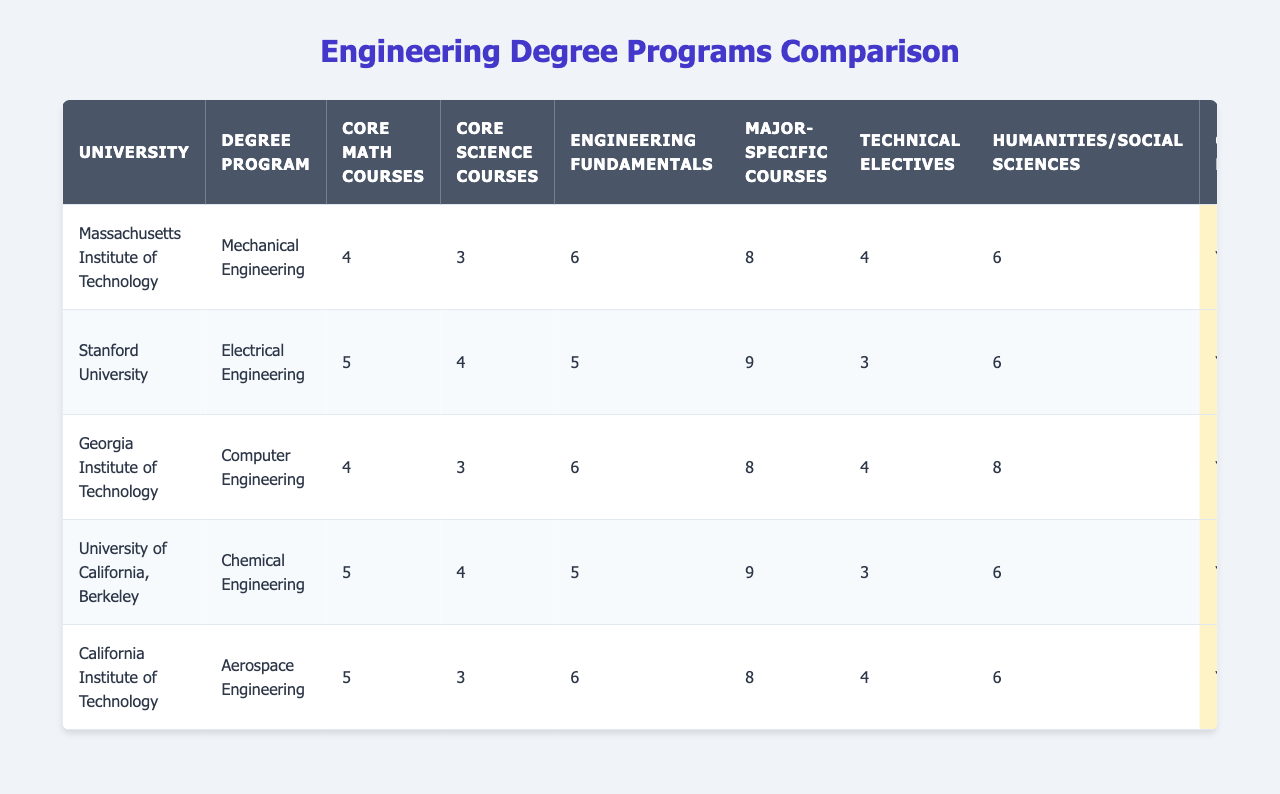What is the university with the most core math courses required for engineering? Referring to the table, Stanford University requires 5 core math courses, which is the highest among all the universities listed.
Answer: Stanford University Which degree program has the highest average class size? By examining the table, the average class size for the Chemical Engineering program at the University of California, Berkeley, is 40, which is the highest.
Answer: Chemical Engineering (University of California, Berkeley) Is the internship requirement mandatory for mechanical engineering programs? The internship requirement for the Mechanical Engineering program at MIT is optional, as indicated in the table.
Answer: No How many total major-specific courses are required across all degree programs? To find the total, we sum the major-specific courses: 8 (Mechanical) + 9 (Electrical) + 8 (Computer) + 9 (Chemical) + 8 (Aerospace) = 42.
Answer: 42 Which engineering program offers the most specialization options? By reviewing the table, the Electrical Engineering program at Stanford University has three specialization options listed and is the most expansive.
Answer: Electrical Engineering (Stanford University) What percentage of the engineering programs require a capstone project? All programs in the table require a capstone project. There are 5 programs, so the percentage is (5 / 5) * 100 = 100%.
Answer: 100% How does the average number of technical electives compare between Electrical Engineering and Aerospace Engineering? The Electrical Engineering program has 3 technical electives, while Aerospace Engineering has 4. The difference is 4 - 3 = 1.
Answer: Aerospace Engineering has 1 more technical elective Which university's engineering program has the smallest class size and what is the size? According to the table, the California Institute of Technology has the smallest average class size of 20.
Answer: California Institute of Technology, 20 If a student is interested in both robotics and power systems, which universities offer relevant specialization options? By checking the table, MIT offers specialization in Robotics, while Stanford offers Power Systems, making these two universities suitable based on interests.
Answer: MIT and Stanford University What is the total number of core science courses required for all engineering programs? The total can be calculated as follows: 3 (Mechanical) + 4 (Electrical) + 3 (Computer) + 4 (Chemical) + 3 (Aerospace) = 17.
Answer: 17 